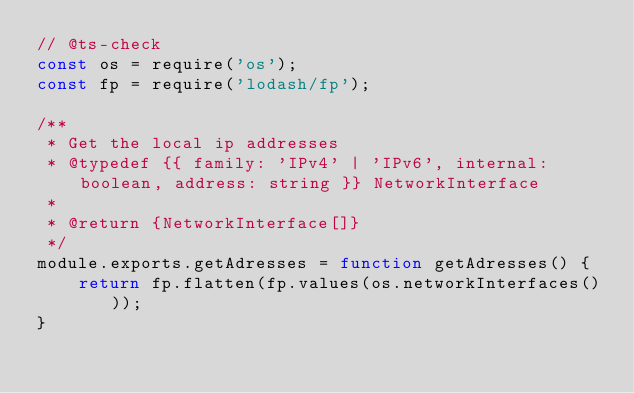<code> <loc_0><loc_0><loc_500><loc_500><_JavaScript_>// @ts-check
const os = require('os');
const fp = require('lodash/fp');

/**
 * Get the local ip addresses
 * @typedef {{ family: 'IPv4' | 'IPv6', internal: boolean, address: string }} NetworkInterface
 *
 * @return {NetworkInterface[]}
 */
module.exports.getAdresses = function getAdresses() {
	return fp.flatten(fp.values(os.networkInterfaces()));
}
</code> 